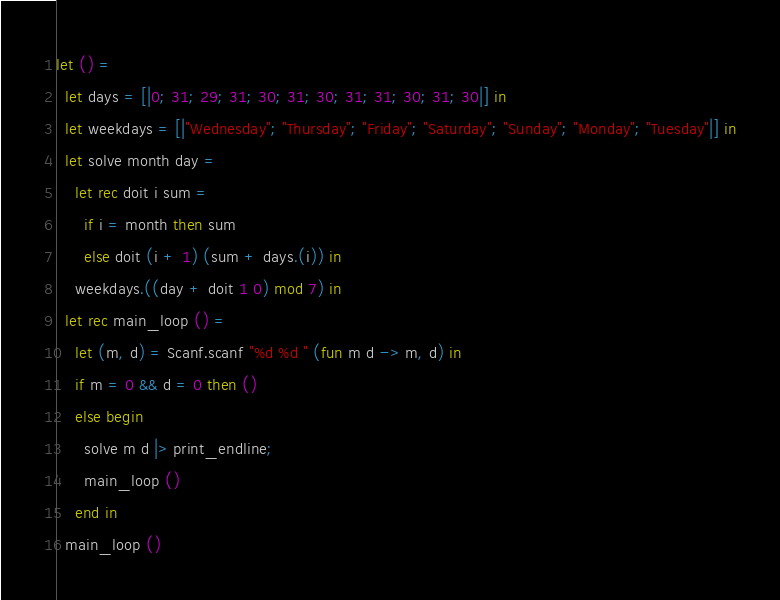<code> <loc_0><loc_0><loc_500><loc_500><_OCaml_>let () =
  let days = [|0; 31; 29; 31; 30; 31; 30; 31; 31; 30; 31; 30|] in
  let weekdays = [|"Wednesday"; "Thursday"; "Friday"; "Saturday"; "Sunday"; "Monday"; "Tuesday"|] in
  let solve month day =
    let rec doit i sum =
      if i = month then sum
      else doit (i + 1) (sum + days.(i)) in
    weekdays.((day + doit 1 0) mod 7) in
  let rec main_loop () =
    let (m, d) = Scanf.scanf "%d %d " (fun m d -> m, d) in
    if m = 0 && d = 0 then ()
    else begin
      solve m d |> print_endline;
      main_loop ()
    end in
  main_loop ()</code> 